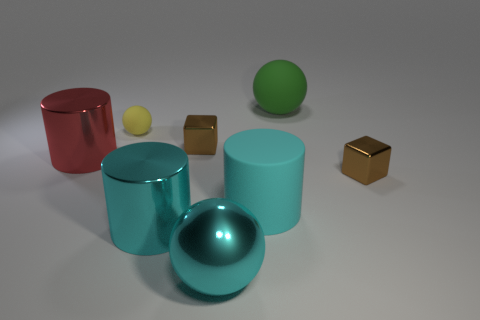Add 2 big matte cylinders. How many objects exist? 10 Subtract all spheres. How many objects are left? 5 Add 1 large cyan things. How many large cyan things exist? 4 Subtract 1 green balls. How many objects are left? 7 Subtract all matte spheres. Subtract all yellow things. How many objects are left? 5 Add 4 cylinders. How many cylinders are left? 7 